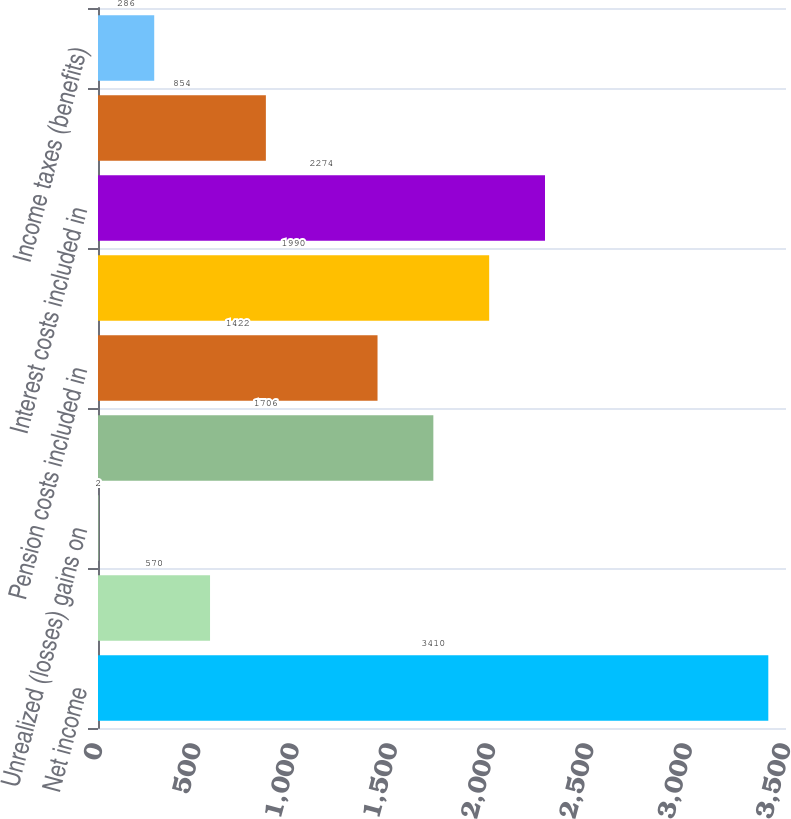<chart> <loc_0><loc_0><loc_500><loc_500><bar_chart><fcel>Net income<fcel>Foreign currency translation<fcel>Unrealized (losses) gains on<fcel>Defined benefit plans<fcel>Pension costs included in<fcel>Change in fair value of<fcel>Interest costs included in<fcel>Other comprehensive income<fcel>Income taxes (benefits)<nl><fcel>3410<fcel>570<fcel>2<fcel>1706<fcel>1422<fcel>1990<fcel>2274<fcel>854<fcel>286<nl></chart> 